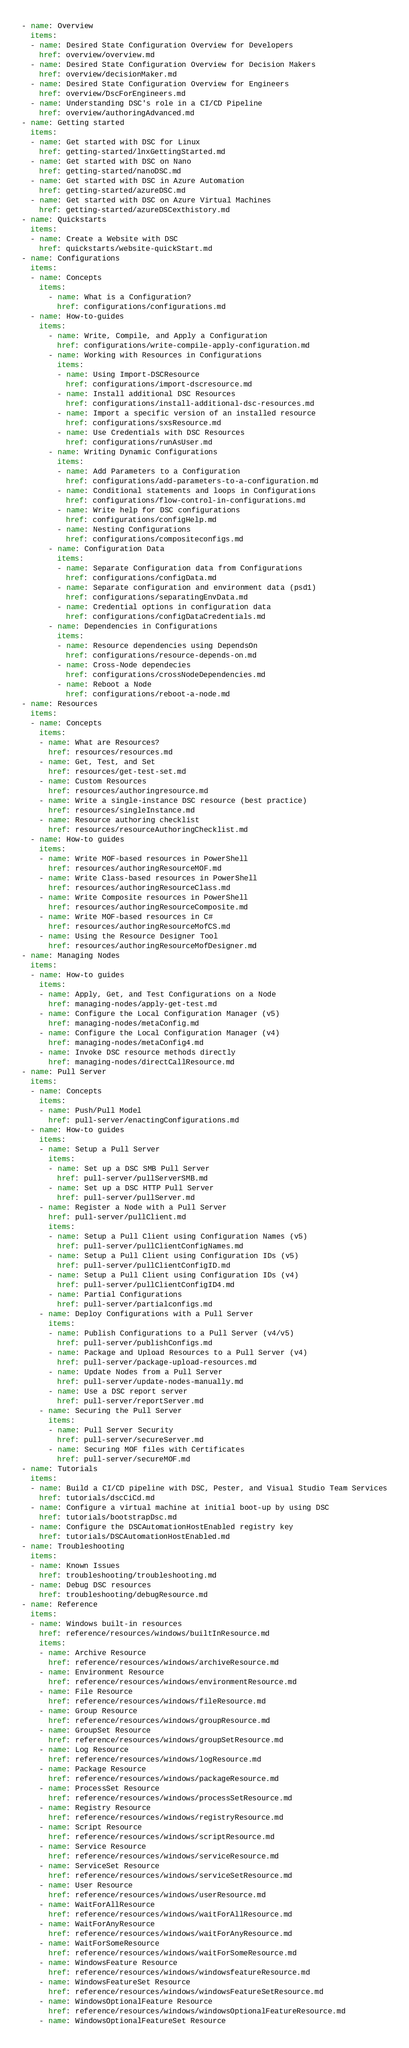<code> <loc_0><loc_0><loc_500><loc_500><_YAML_>- name: Overview
  items:
  - name: Desired State Configuration Overview for Developers
    href: overview/overview.md
  - name: Desired State Configuration Overview for Decision Makers
    href: overview/decisionMaker.md
  - name: Desired State Configuration Overview for Engineers
    href: overview/DscForEngineers.md
  - name: Understanding DSC's role in a CI/CD Pipeline
    href: overview/authoringAdvanced.md
- name: Getting started
  items:
  - name: Get started with DSC for Linux
    href: getting-started/lnxGettingStarted.md
  - name: Get started with DSC on Nano
    href: getting-started/nanoDSC.md
  - name: Get started with DSC in Azure Automation
    href: getting-started/azureDSC.md
  - name: Get started with DSC on Azure Virtual Machines
    href: getting-started/azureDSCexthistory.md
- name: Quickstarts
  items:
  - name: Create a Website with DSC
    href: quickstarts/website-quickStart.md
- name: Configurations
  items:
  - name: Concepts
    items:
      - name: What is a Configuration?
        href: configurations/configurations.md
  - name: How-to-guides
    items:
      - name: Write, Compile, and Apply a Configuration
        href: configurations/write-compile-apply-configuration.md
      - name: Working with Resources in Configurations
        items:
        - name: Using Import-DSCResource
          href: configurations/import-dscresource.md
        - name: Install additional DSC Resources
          href: configurations/install-additional-dsc-resources.md
        - name: Import a specific version of an installed resource
          href: configurations/sxsResource.md
        - name: Use Credentials with DSC Resources
          href: configurations/runAsUser.md
      - name: Writing Dynamic Configurations
        items:
        - name: Add Parameters to a Configuration
          href: configurations/add-parameters-to-a-configuration.md
        - name: Conditional statements and loops in Configurations
          href: configurations/flow-control-in-configurations.md
        - name: Write help for DSC configurations
          href: configurations/configHelp.md
        - name: Nesting Configurations
          href: configurations/compositeconfigs.md
      - name: Configuration Data
        items:
        - name: Separate Configuration data from Configurations
          href: configurations/configData.md
        - name: Separate configuration and environment data (psd1)
          href: configurations/separatingEnvData.md
        - name: Credential options in configuration data
          href: configurations/configDataCredentials.md
      - name: Dependencies in Configurations
        items:
        - name: Resource dependencies using DependsOn
          href: configurations/resource-depends-on.md
        - name: Cross-Node dependecies
          href: configurations/crossNodeDependencies.md
        - name: Reboot a Node
          href: configurations/reboot-a-node.md
- name: Resources
  items:
  - name: Concepts
    items:
    - name: What are Resources?
      href: resources/resources.md
    - name: Get, Test, and Set
      href: resources/get-test-set.md
    - name: Custom Resources
      href: resources/authoringresource.md
    - name: Write a single-instance DSC resource (best practice)
      href: resources/singleInstance.md
    - name: Resource authoring checklist
      href: resources/resourceAuthoringChecklist.md
  - name: How-to guides
    items:
    - name: Write MOF-based resources in PowerShell
      href: resources/authoringResourceMOF.md
    - name: Write Class-based resources in PowerShell
      href: resources/authoringResourceClass.md
    - name: Write Composite resources in PowerShell
      href: resources/authoringResourceComposite.md
    - name: Write MOF-based resources in C#
      href: resources/authoringResourceMofCS.md
    - name: Using the Resource Designer Tool
      href: resources/authoringResourceMofDesigner.md
- name: Managing Nodes
  items:
  - name: How-to guides
    items:
    - name: Apply, Get, and Test Configurations on a Node
      href: managing-nodes/apply-get-test.md
    - name: Configure the Local Configuration Manager (v5)
      href: managing-nodes/metaConfig.md
    - name: Configure the Local Configuration Manager (v4)
      href: managing-nodes/metaConfig4.md
    - name: Invoke DSC resource methods directly
      href: managing-nodes/directCallResource.md
- name: Pull Server
  items:
  - name: Concepts
    items:
    - name: Push/Pull Model
      href: pull-server/enactingConfigurations.md
  - name: How-to guides
    items:
    - name: Setup a Pull Server
      items:
      - name: Set up a DSC SMB Pull Server
        href: pull-server/pullServerSMB.md
      - name: Set up a DSC HTTP Pull Server
        href: pull-server/pullServer.md
    - name: Register a Node with a Pull Server
      href: pull-server/pullClient.md
      items:
      - name: Setup a Pull Client using Configuration Names (v5)
        href: pull-server/pullClientConfigNames.md
      - name: Setup a Pull Client using Configuration IDs (v5)
        href: pull-server/pullClientConfigID.md
      - name: Setup a Pull Client using Configuration IDs (v4)
        href: pull-server/pullClientConfigID4.md
      - name: Partial Configurations
        href: pull-server/partialconfigs.md
    - name: Deploy Configurations with a Pull Server
      items:
      - name: Publish Configurations to a Pull Server (v4/v5)
        href: pull-server/publishConfigs.md
      - name: Package and Upload Resources to a Pull Server (v4)
        href: pull-server/package-upload-resources.md
      - name: Update Nodes from a Pull Server
        href: pull-server/update-nodes-manually.md
      - name: Use a DSC report server
        href: pull-server/reportServer.md
    - name: Securing the Pull Server
      items:
      - name: Pull Server Security
        href: pull-server/secureServer.md
      - name: Securing MOF files with Certificates
        href: pull-server/secureMOF.md
- name: Tutorials
  items:
  - name: Build a CI/CD pipeline with DSC, Pester, and Visual Studio Team Services
    href: tutorials/dscCiCd.md
  - name: Configure a virtual machine at initial boot-up by using DSC
    href: tutorials/bootstrapDsc.md
  - name: Configure the DSCAutomationHostEnabled registry key
    href: tutorials/DSCAutomationHostEnabled.md
- name: Troubleshooting
  items:
  - name: Known Issues
    href: troubleshooting/troubleshooting.md
  - name: Debug DSC resources
    href: troubleshooting/debugResource.md
- name: Reference
  items:
  - name: Windows built-in resources
    href: reference/resources/windows/builtInResource.md
    items:
    - name: Archive Resource
      href: reference/resources/windows/archiveResource.md
    - name: Environment Resource
      href: reference/resources/windows/environmentResource.md
    - name: File Resource
      href: reference/resources/windows/fileResource.md
    - name: Group Resource
      href: reference/resources/windows/groupResource.md
    - name: GroupSet Resource
      href: reference/resources/windows/groupSetResource.md
    - name: Log Resource
      href: reference/resources/windows/logResource.md
    - name: Package Resource
      href: reference/resources/windows/packageResource.md
    - name: ProcessSet Resource
      href: reference/resources/windows/processSetResource.md
    - name: Registry Resource
      href: reference/resources/windows/registryResource.md
    - name: Script Resource
      href: reference/resources/windows/scriptResource.md
    - name: Service Resource
      href: reference/resources/windows/serviceResource.md
    - name: ServiceSet Resource
      href: reference/resources/windows/serviceSetResource.md
    - name: User Resource
      href: reference/resources/windows/userResource.md
    - name: WaitForAllResource
      href: reference/resources/windows/waitForAllResource.md
    - name: WaitForAnyResource
      href: reference/resources/windows/waitForAnyResource.md
    - name: WaitForSomeResource
      href: reference/resources/windows/waitForSomeResource.md
    - name: WindowsFeature Resource
      href: reference/resources/windows/windowsfeatureResource.md
    - name: WindowsFeatureSet Resource
      href: reference/resources/windows/windowsFeatureSetResource.md
    - name: WindowsOptionalFeature Resource
      href: reference/resources/windows/windowsOptionalFeatureResource.md
    - name: WindowsOptionalFeatureSet Resource</code> 